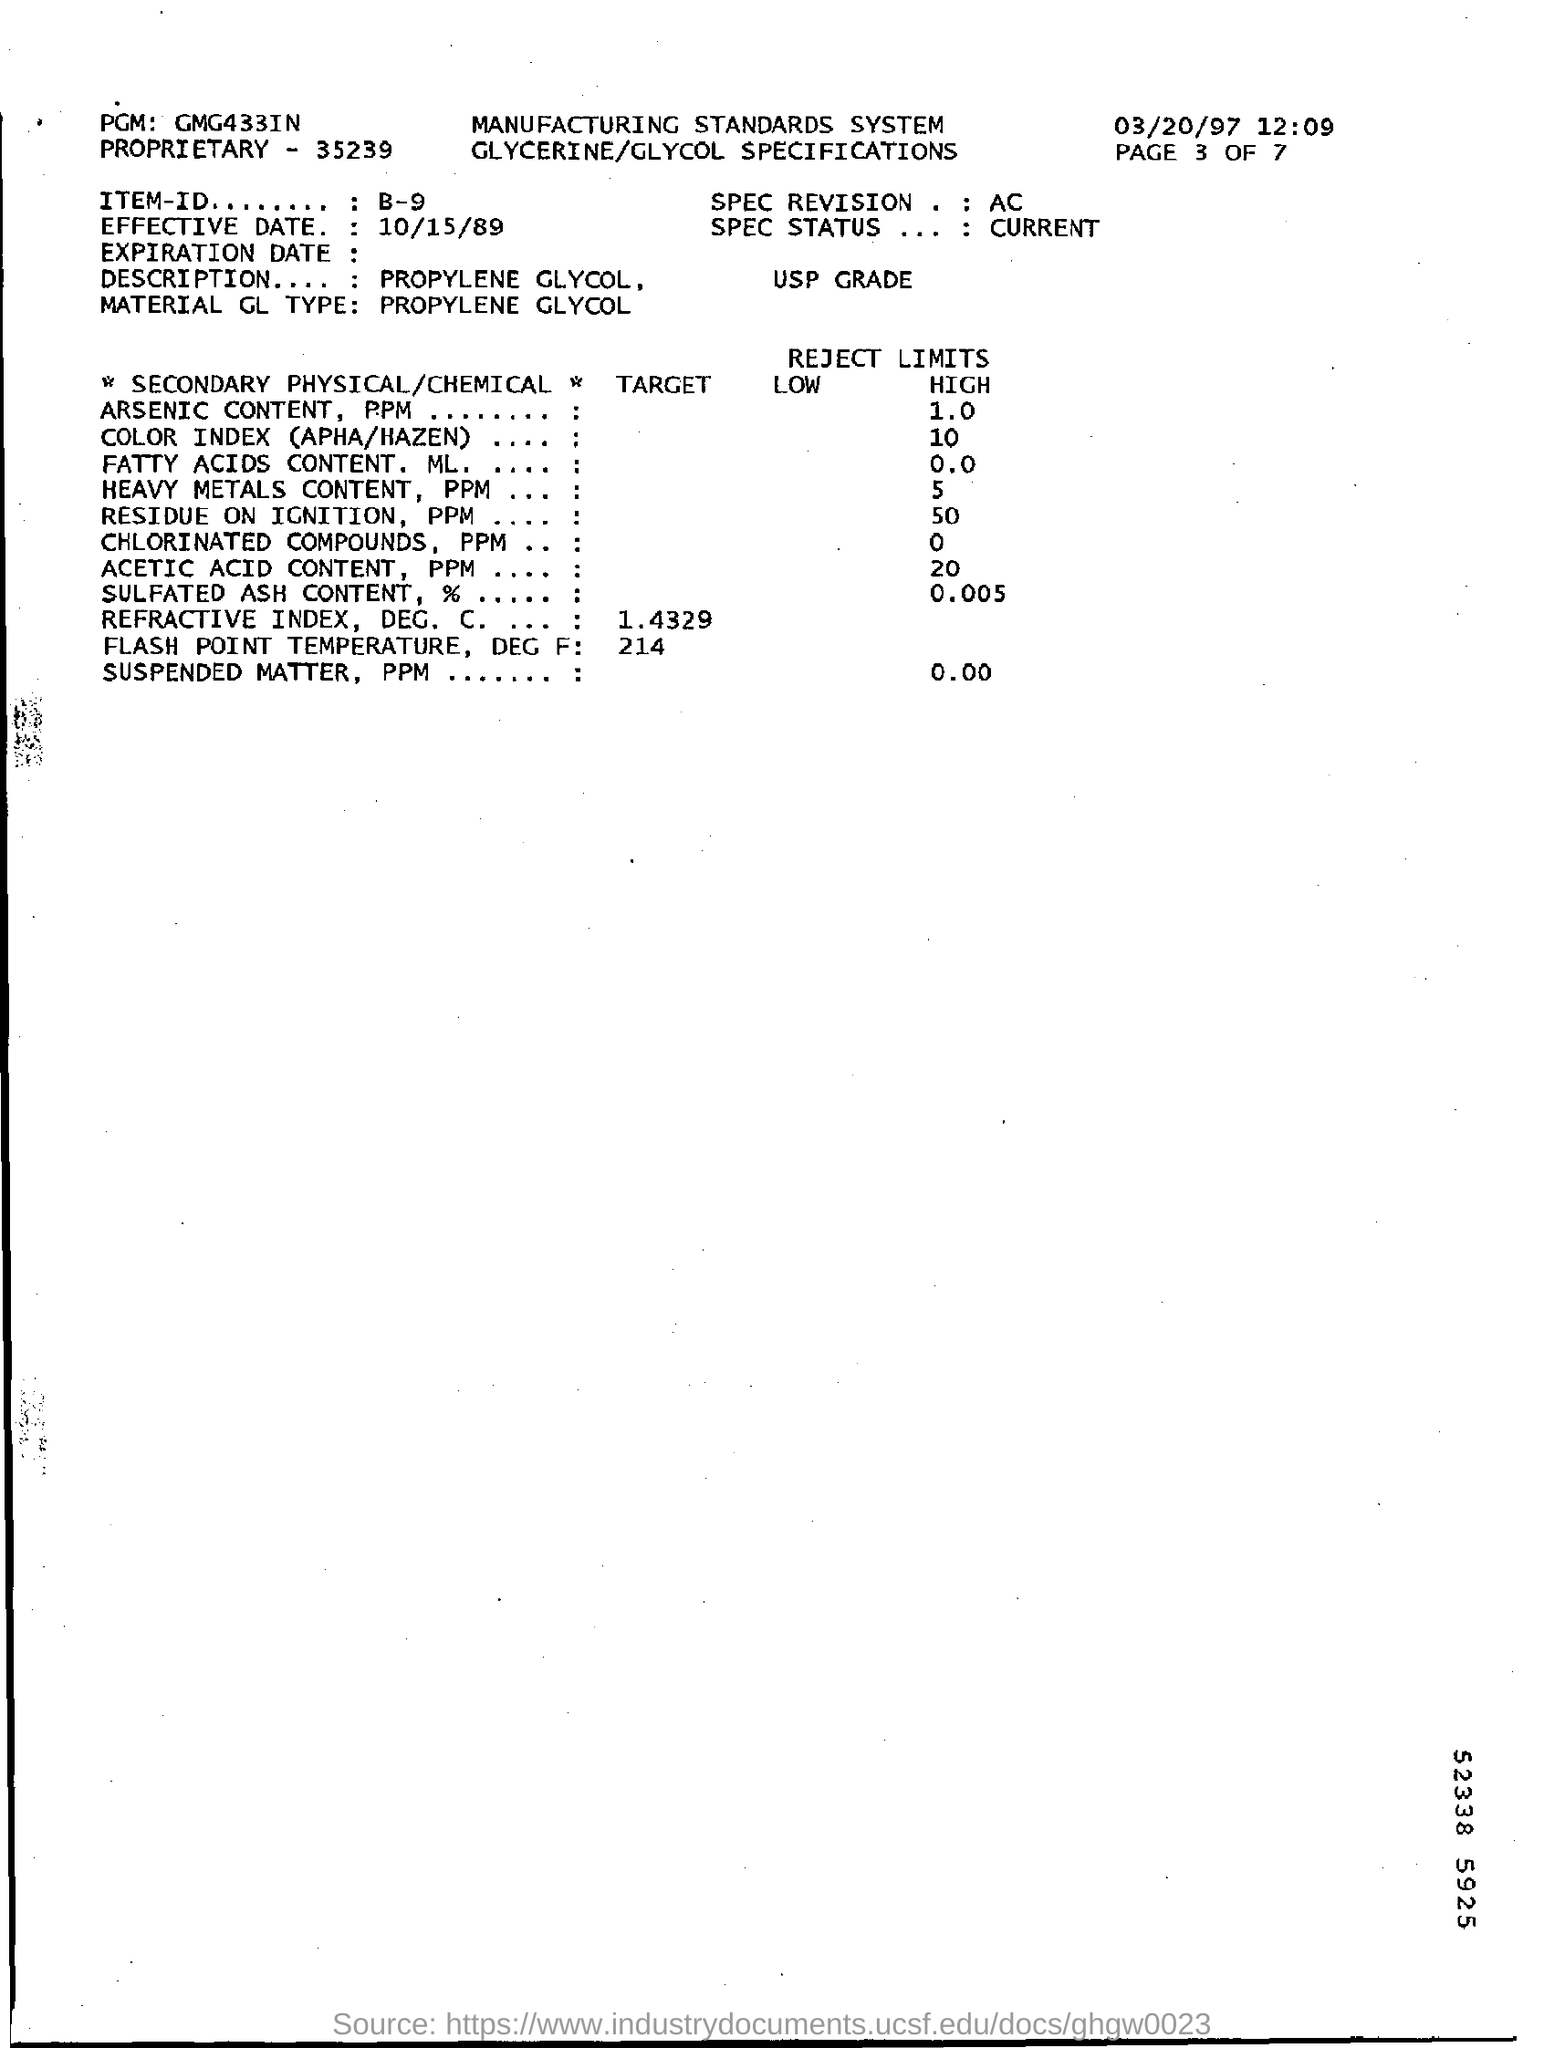What is the time mentioned in this document?
Offer a terse response. 12.09. What is the page number of the document?
Provide a succinct answer. 3. What is the "item ID" Mentioned in this document?
Ensure brevity in your answer.  B-9. 